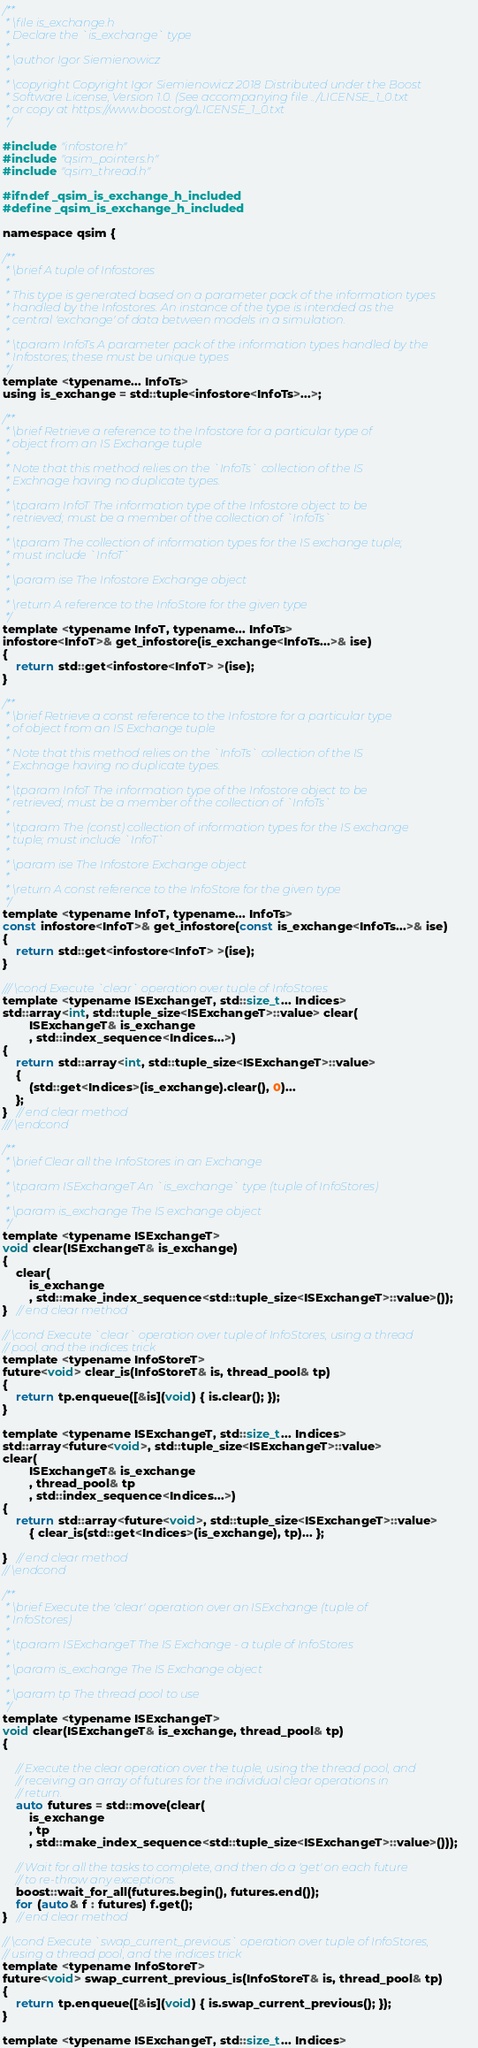Convert code to text. <code><loc_0><loc_0><loc_500><loc_500><_C_>/**
 * \file is_exchange.h
 * Declare the `is_exchange` type
 * 
 * \author Igor Siemienowicz
 * 
 * \copyright Copyright Igor Siemienowicz 2018 Distributed under the Boost
 * Software License, Version 1.0. (See accompanying file ../LICENSE_1_0.txt
 * or copy at https://www.boost.org/LICENSE_1_0.txt
 */

#include "infostore.h"
#include "qsim_pointers.h"
#include "qsim_thread.h"

#ifndef _qsim_is_exchange_h_included
#define _qsim_is_exchange_h_included

namespace qsim {

/**
 * \brief A tuple of Infostores
 *
 * This type is generated based on a parameter pack of the information types
 * handled by the Infostores. An instance of the type is intended as the
 * central 'exchange' of data between models in a simulation.
 *
 * \tparam InfoTs A parameter pack of the information types handled by the
 * Infostores; these must be unique types
 */
template <typename... InfoTs>
using is_exchange = std::tuple<infostore<InfoTs>...>;

/**
 * \brief Retrieve a reference to the Infostore for a particular type of
 * object from an IS Exchange tuple
 *
 * Note that this method relies on the `InfoTs` collection of the IS
 * Exchnage having no duplicate types.
 *
 * \tparam InfoT The information type of the Infostore object to be
 * retrieved; must be a member of the collection of `InfoTs`
 * 
 * \tparam The collection of information types for the IS exchange tuple;
 * must include `InfoT`
 *
 * \param ise The Infostore Exchange object
 *
 * \return A reference to the InfoStore for the given type
 */
template <typename InfoT, typename... InfoTs>
infostore<InfoT>& get_infostore(is_exchange<InfoTs...>& ise)
{
    return std::get<infostore<InfoT> >(ise);
}

/**
 * \brief Retrieve a const reference to the Infostore for a particular type
 * of object from an IS Exchange tuple
 *
 * Note that this method relies on the `InfoTs` collection of the IS
 * Exchnage having no duplicate types.
 *
 * \tparam InfoT The information type of the Infostore object to be
 * retrieved; must be a member of the collection of `InfoTs`
 * 
 * \tparam The (const) collection of information types for the IS exchange
 * tuple; must include `InfoT`
 *
 * \param ise The Infostore Exchange object
 *
 * \return A const reference to the InfoStore for the given type
 */
template <typename InfoT, typename... InfoTs>
const infostore<InfoT>& get_infostore(const is_exchange<InfoTs...>& ise)
{
    return std::get<infostore<InfoT> >(ise);
}

/// \cond Execute `clear` operation over tuple of InfoStores
template <typename ISExchangeT, std::size_t... Indices>
std::array<int, std::tuple_size<ISExchangeT>::value> clear(
        ISExchangeT& is_exchange
        , std::index_sequence<Indices...>)
{
    return std::array<int, std::tuple_size<ISExchangeT>::value>
    {
        (std::get<Indices>(is_exchange).clear(), 0)...
    };
}   // end clear method
/// \endcond

/**
 * \brief Clear all the InfoStores in an Exchange
 *
 * \tparam ISExchangeT An `is_exchange` type (tuple of InfoStores)
 *
 * \param is_exchange The IS exchange object
 */
template <typename ISExchangeT>
void clear(ISExchangeT& is_exchange)
{
    clear(
        is_exchange
        , std::make_index_sequence<std::tuple_size<ISExchangeT>::value>());
}   // end clear method

// \cond Execute `clear` operation over tuple of InfoStores, using a thread
// pool, and the indices trick
template <typename InfoStoreT>
future<void> clear_is(InfoStoreT& is, thread_pool& tp)
{
    return tp.enqueue([&is](void) { is.clear(); });
}

template <typename ISExchangeT, std::size_t... Indices>
std::array<future<void>, std::tuple_size<ISExchangeT>::value>
clear(
        ISExchangeT& is_exchange
        , thread_pool& tp
        , std::index_sequence<Indices...>)
{
    return std::array<future<void>, std::tuple_size<ISExchangeT>::value>
        { clear_is(std::get<Indices>(is_exchange), tp)... };

}   // end clear method
// \endcond

/**
 * \brief Execute the 'clear' operation over an ISExchange (tuple of
 * InfoStores)
 *
 * \tparam ISExchangeT The IS Exchange - a tuple of InfoStores
 *
 * \param is_exchange The IS Exchange object
 *
 * \param tp The thread pool to use
 */
template <typename ISExchangeT>
void clear(ISExchangeT& is_exchange, thread_pool& tp)
{

    // Execute the clear operation over the tuple, using the thread pool, and
    // receiving an array of futures for the individual clear operations in
    // return.
    auto futures = std::move(clear(
        is_exchange
        , tp
        , std::make_index_sequence<std::tuple_size<ISExchangeT>::value>()));

    // Wait for all the tasks to complete, and then do a 'get' on each future
    // to re-throw any exceptions.
    boost::wait_for_all(futures.begin(), futures.end());
    for (auto& f : futures) f.get();
}   // end clear method

// \cond Execute `swap_current_previous` operation over tuple of InfoStores,
// using a thread pool, and the indices trick
template <typename InfoStoreT>
future<void> swap_current_previous_is(InfoStoreT& is, thread_pool& tp)
{
    return tp.enqueue([&is](void) { is.swap_current_previous(); });
}

template <typename ISExchangeT, std::size_t... Indices></code> 